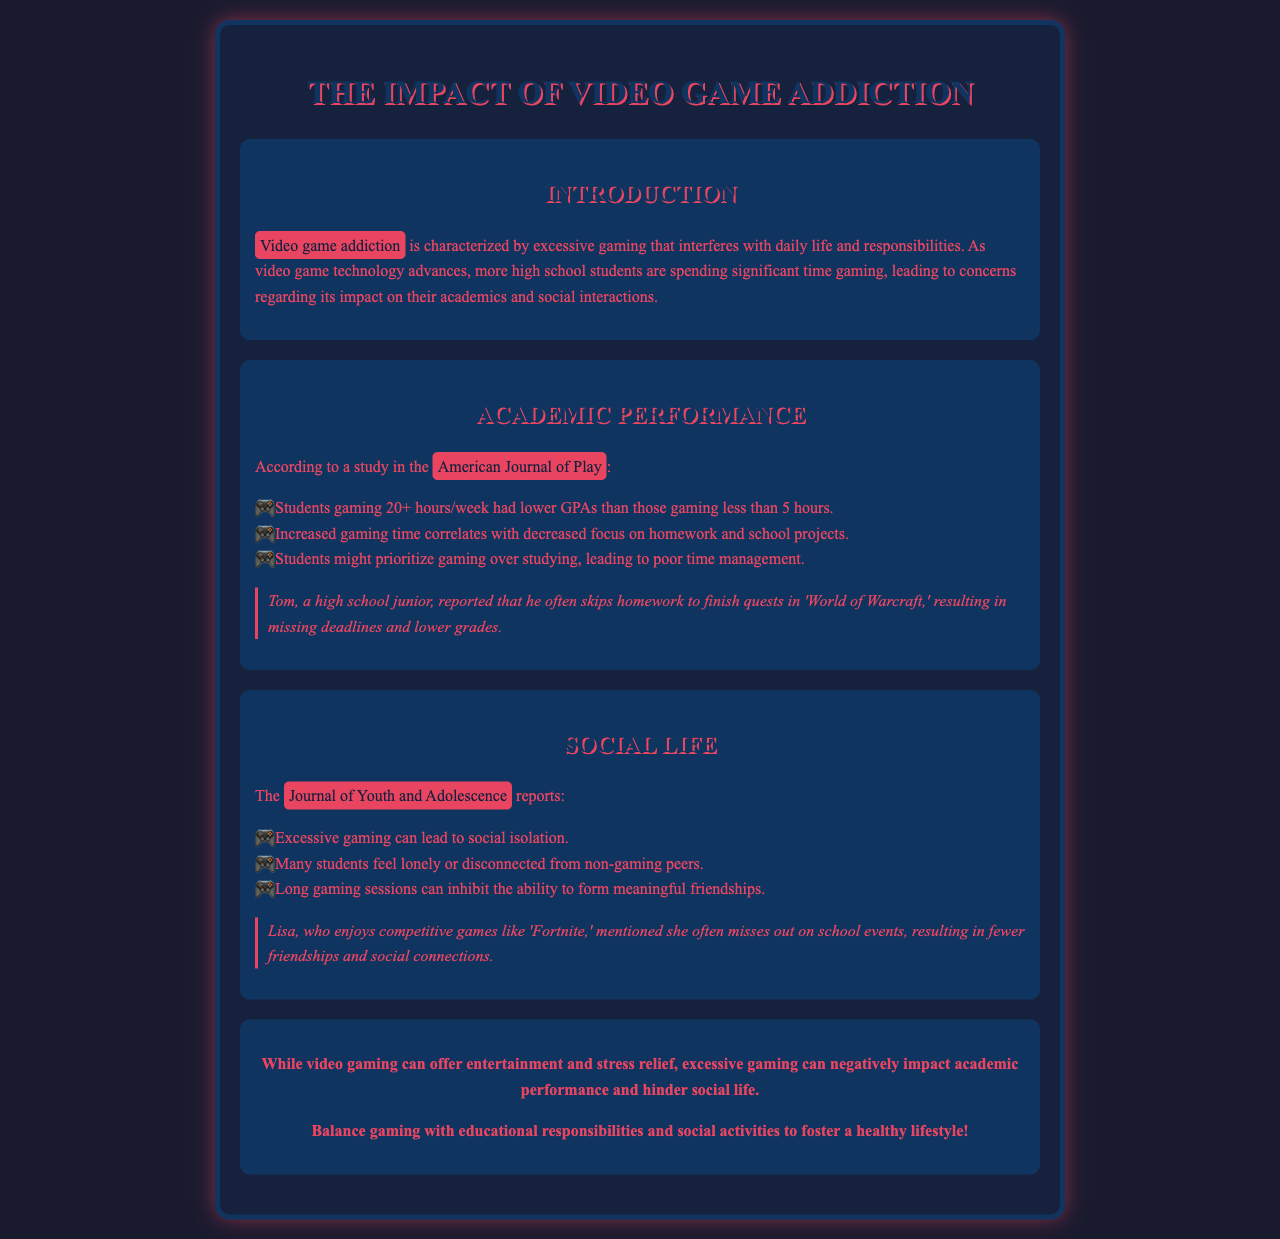What is characterized by excessive gaming? The document defines video game addiction as being characterized by excessive gaming that interferes with daily life and responsibilities.
Answer: Video game addiction How many hours per week lead to lower GPAs? The document states that students gaming 20+ hours/week had lower GPAs than those gaming less than 5 hours.
Answer: 20+ hours What impact does increased gaming time have on homework? The document mentions that increased gaming time correlates with decreased focus on homework and school projects.
Answer: Decreased focus What effect can excessive gaming have on social life? According to the document, excessive gaming can lead to social isolation.
Answer: Social isolation What does Tom report doing instead of homework? Tom reported that he often skips homework to finish quests in 'World of Warcraft.'
Answer: Skips homework Which game does Lisa enjoy playing? The document states that Lisa enjoys competitive games like 'Fortnite.'
Answer: Fortnite What should be balanced with gaming for a healthy lifestyle? The conclusion of the document suggests balancing gaming with educational responsibilities and social activities.
Answer: Educational responsibilities Which journal discusses the negative impacts on social life? The document cites the Journal of Youth and Adolescence as reporting the effects of gaming on social life.
Answer: Journal of Youth and Adolescence What is the overall conclusion about video gaming? The conclusion summarizes that excessive gaming can negatively impact academic performance and hinder social life.
Answer: Negative impact 